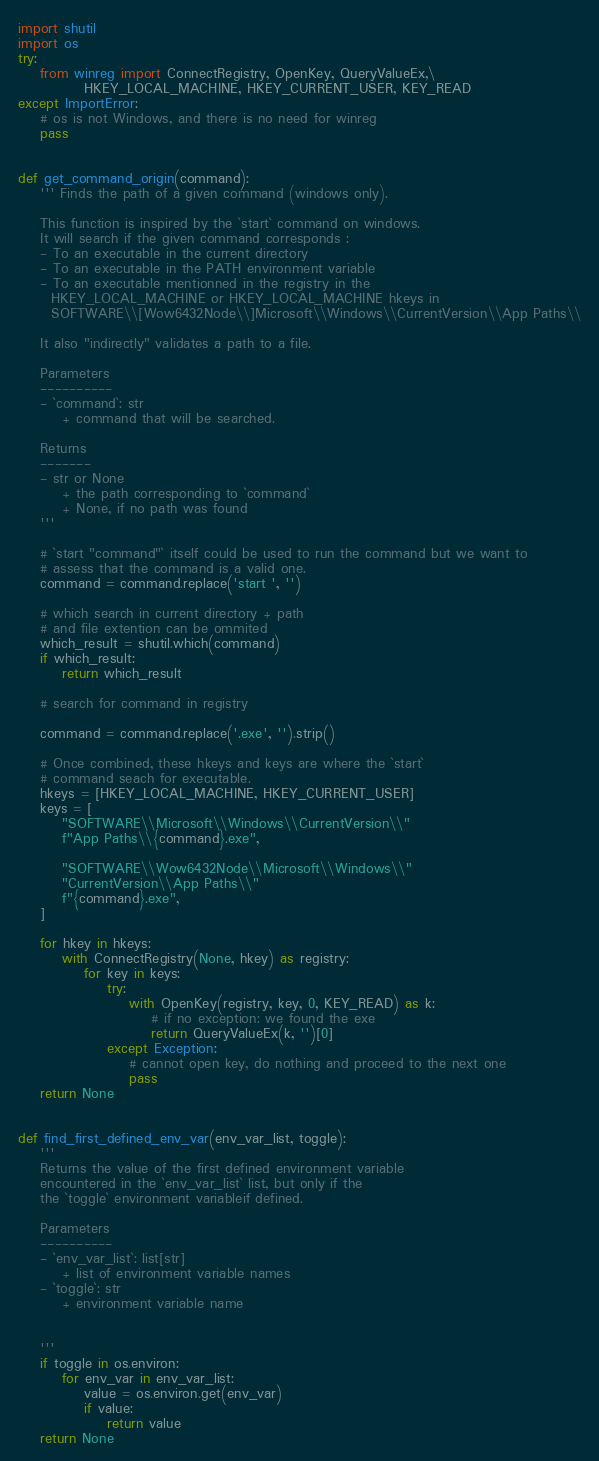Convert code to text. <code><loc_0><loc_0><loc_500><loc_500><_Python_>import shutil
import os
try:
    from winreg import ConnectRegistry, OpenKey, QueryValueEx,\
            HKEY_LOCAL_MACHINE, HKEY_CURRENT_USER, KEY_READ
except ImportError:
    # os is not Windows, and there is no need for winreg
    pass


def get_command_origin(command):
    ''' Finds the path of a given command (windows only).

    This function is inspired by the `start` command on windows.
    It will search if the given command corresponds :
    - To an executable in the current directory
    - To an executable in the PATH environment variable
    - To an executable mentionned in the registry in the
      HKEY_LOCAL_MACHINE or HKEY_LOCAL_MACHINE hkeys in
      SOFTWARE\\[Wow6432Node\\]Microsoft\\Windows\\CurrentVersion\\App Paths\\

    It also "indirectly" validates a path to a file.

    Parameters
    ----------
    - `command`: str
        + command that will be searched.

    Returns
    -------
    - str or None
        + the path corresponding to `command`
        + None, if no path was found
    '''

    # `start "command"` itself could be used to run the command but we want to
    # assess that the command is a valid one.
    command = command.replace('start ', '')

    # which search in current directory + path
    # and file extention can be ommited
    which_result = shutil.which(command)
    if which_result:
        return which_result

    # search for command in registry

    command = command.replace('.exe', '').strip()

    # Once combined, these hkeys and keys are where the `start`
    # command seach for executable.
    hkeys = [HKEY_LOCAL_MACHINE, HKEY_CURRENT_USER]
    keys = [
        "SOFTWARE\\Microsoft\\Windows\\CurrentVersion\\"
        f"App Paths\\{command}.exe",

        "SOFTWARE\\Wow6432Node\\Microsoft\\Windows\\"
        "CurrentVersion\\App Paths\\"
        f"{command}.exe",
    ]

    for hkey in hkeys:
        with ConnectRegistry(None, hkey) as registry:
            for key in keys:
                try:
                    with OpenKey(registry, key, 0, KEY_READ) as k:
                        # if no exception: we found the exe
                        return QueryValueEx(k, '')[0]
                except Exception:
                    # cannot open key, do nothing and proceed to the next one
                    pass
    return None


def find_first_defined_env_var(env_var_list, toggle):
    '''
    Returns the value of the first defined environment variable
    encountered in the `env_var_list` list, but only if the
    the `toggle` environment variableif defined.

    Parameters
    ----------
    - `env_var_list`: list[str]
        + list of environment variable names
    - `toggle`: str
        + environment variable name


    '''
    if toggle in os.environ:
        for env_var in env_var_list:
            value = os.environ.get(env_var)
            if value:
                return value
    return None
</code> 